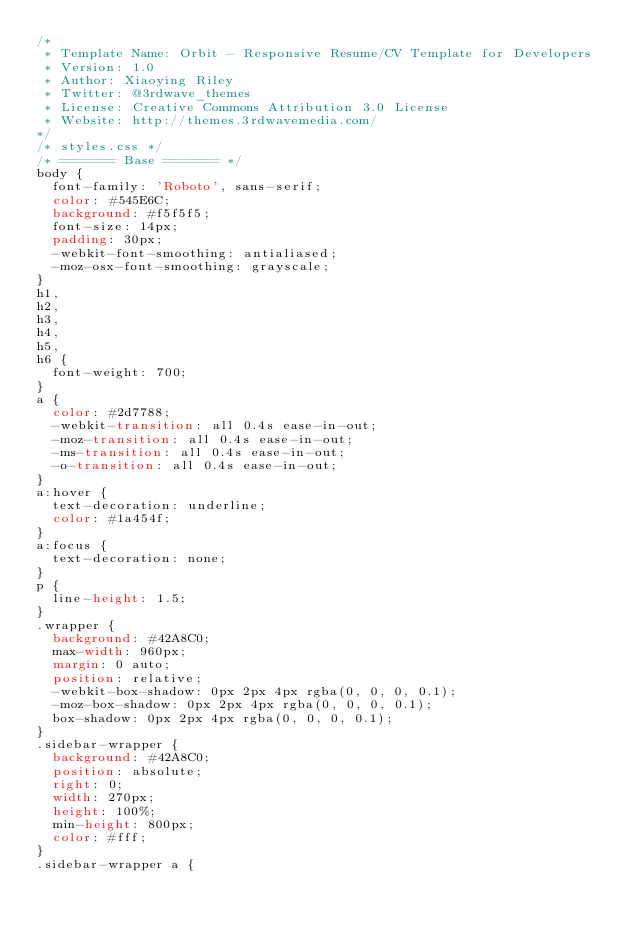Convert code to text. <code><loc_0><loc_0><loc_500><loc_500><_CSS_>/*   
 * Template Name: Orbit - Responsive Resume/CV Template for Developers
 * Version: 1.0
 * Author: Xiaoying Riley
 * Twitter: @3rdwave_themes
 * License: Creative Commons Attribution 3.0 License
 * Website: http://themes.3rdwavemedia.com/
*/
/* styles.css */
/* ======= Base ======= */
body {
  font-family: 'Roboto', sans-serif;
  color: #545E6C;
  background: #f5f5f5;
  font-size: 14px;
  padding: 30px;
  -webkit-font-smoothing: antialiased;
  -moz-osx-font-smoothing: grayscale;
}
h1,
h2,
h3,
h4,
h5,
h6 {
  font-weight: 700;
}
a {
  color: #2d7788;
  -webkit-transition: all 0.4s ease-in-out;
  -moz-transition: all 0.4s ease-in-out;
  -ms-transition: all 0.4s ease-in-out;
  -o-transition: all 0.4s ease-in-out;
}
a:hover {
  text-decoration: underline;
  color: #1a454f;
}
a:focus {
  text-decoration: none;
}
p {
  line-height: 1.5;
}
.wrapper {
  background: #42A8C0;
  max-width: 960px;
  margin: 0 auto;
  position: relative;
  -webkit-box-shadow: 0px 2px 4px rgba(0, 0, 0, 0.1);
  -moz-box-shadow: 0px 2px 4px rgba(0, 0, 0, 0.1);
  box-shadow: 0px 2px 4px rgba(0, 0, 0, 0.1);
}
.sidebar-wrapper {
  background: #42A8C0;
  position: absolute;
  right: 0;
  width: 270px;
  height: 100%;
  min-height: 800px;
  color: #fff;
}
.sidebar-wrapper a {</code> 